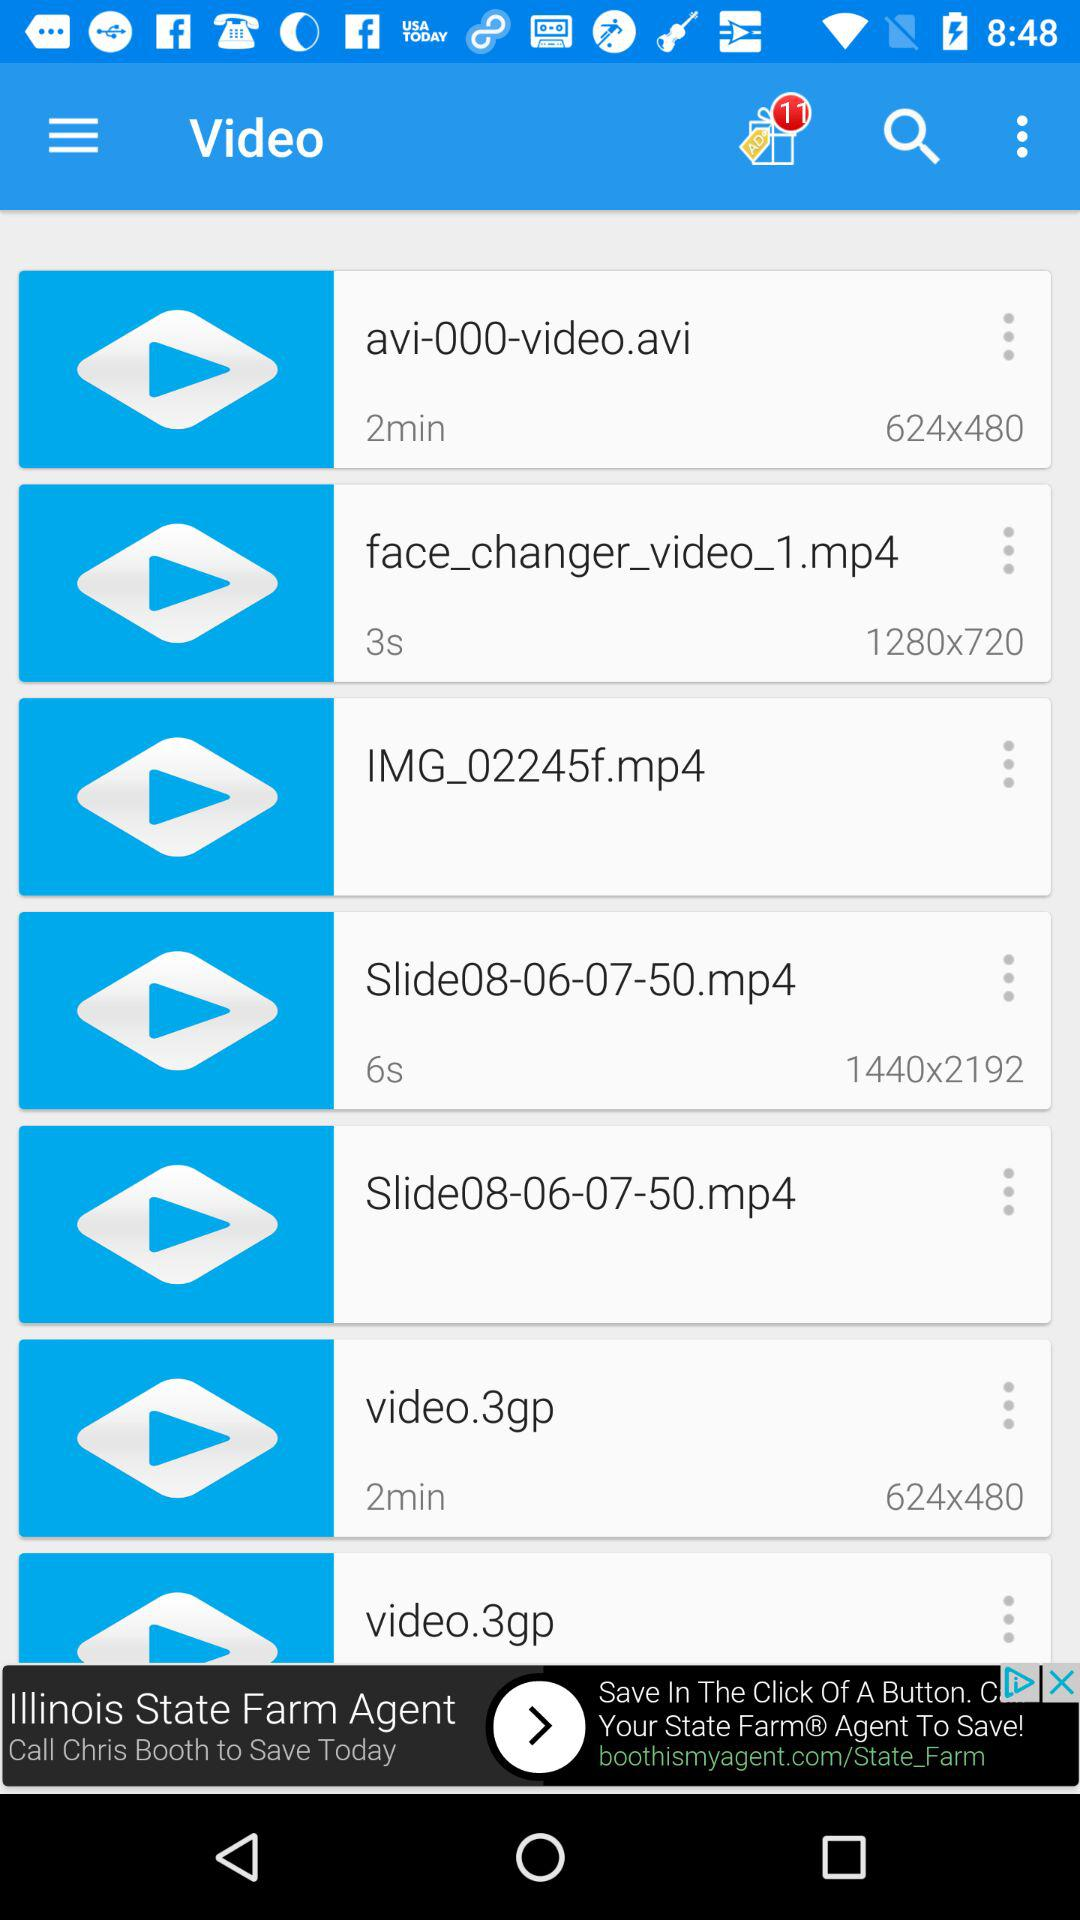How many unseen gifts are there? There are 11 unseen gifts. 